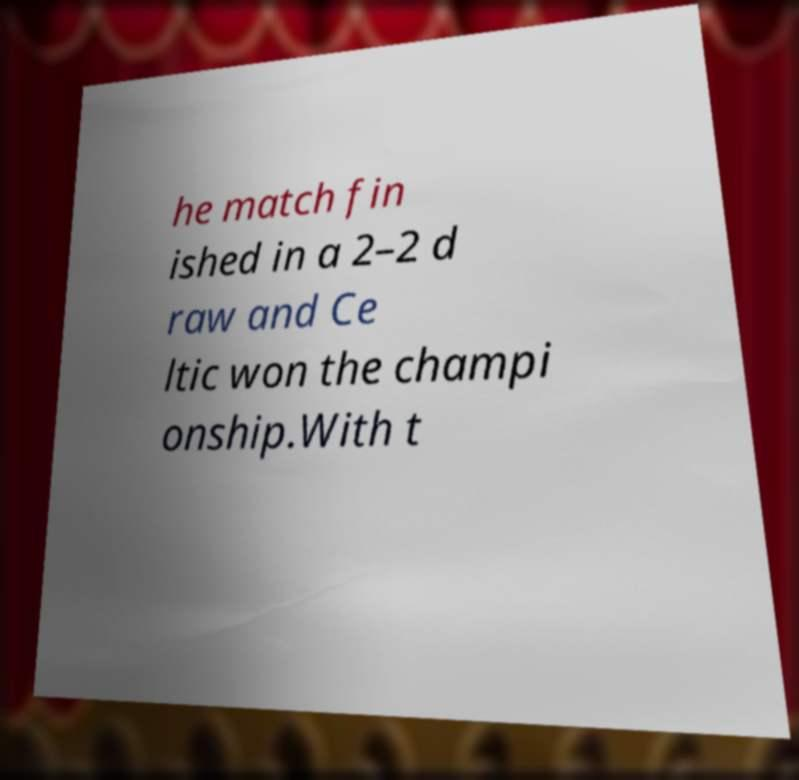Please read and relay the text visible in this image. What does it say? he match fin ished in a 2–2 d raw and Ce ltic won the champi onship.With t 